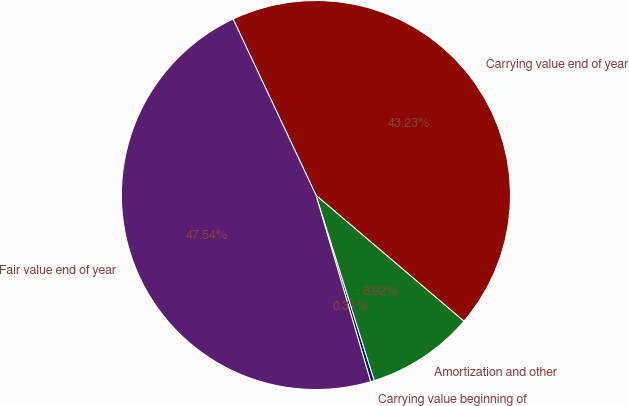<chart> <loc_0><loc_0><loc_500><loc_500><pie_chart><fcel>Carrying value beginning of<fcel>Amortization and other<fcel>Carrying value end of year<fcel>Fair value end of year<nl><fcel>0.31%<fcel>8.92%<fcel>43.23%<fcel>47.54%<nl></chart> 